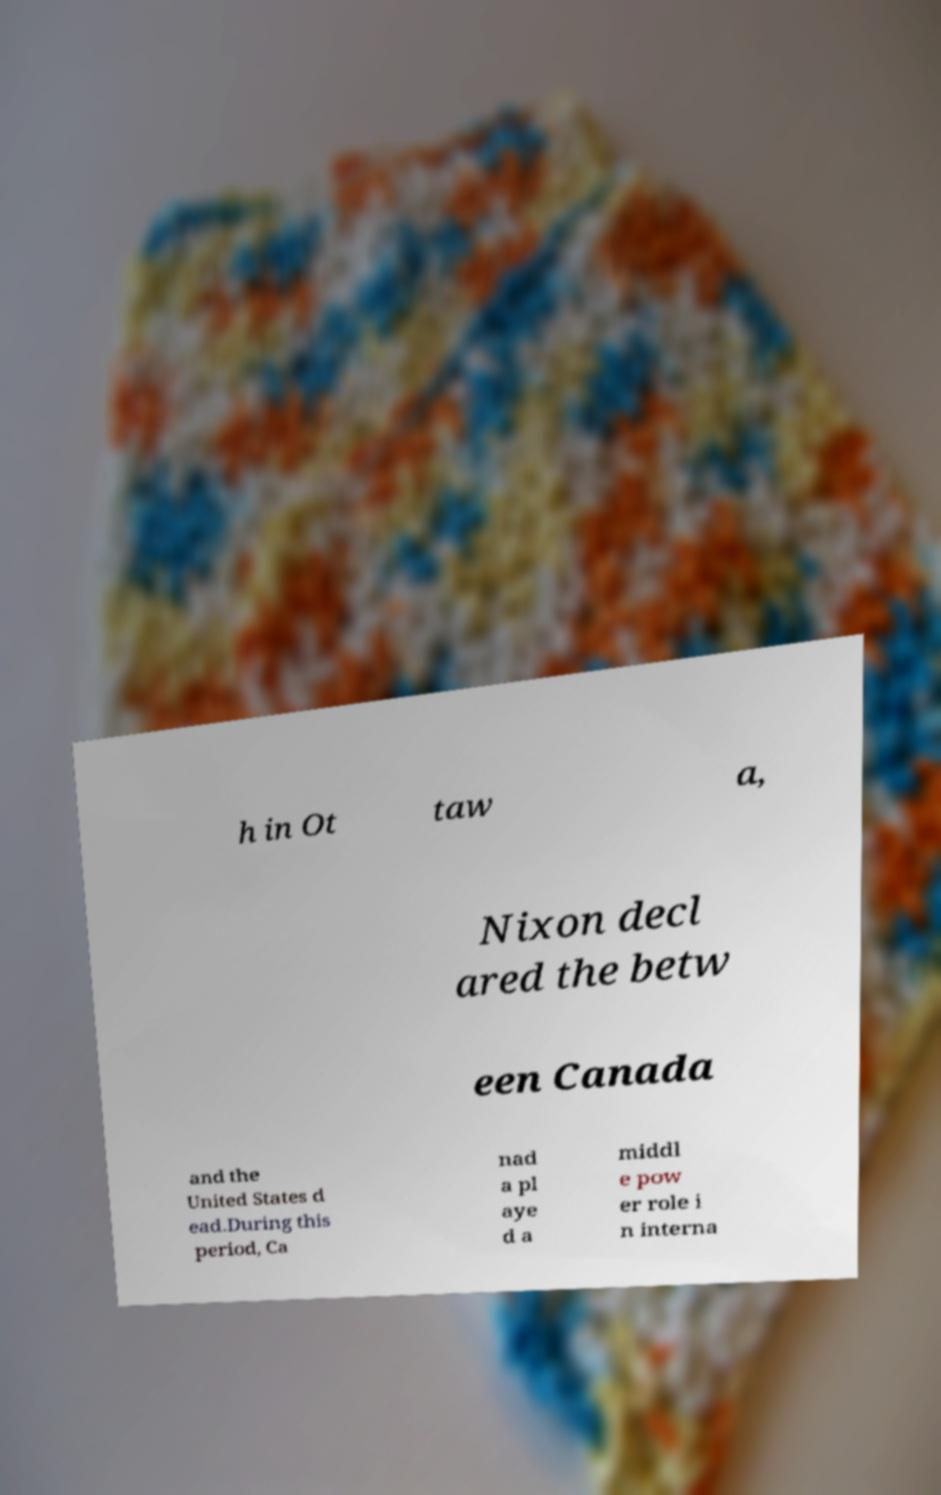For documentation purposes, I need the text within this image transcribed. Could you provide that? h in Ot taw a, Nixon decl ared the betw een Canada and the United States d ead.During this period, Ca nad a pl aye d a middl e pow er role i n interna 